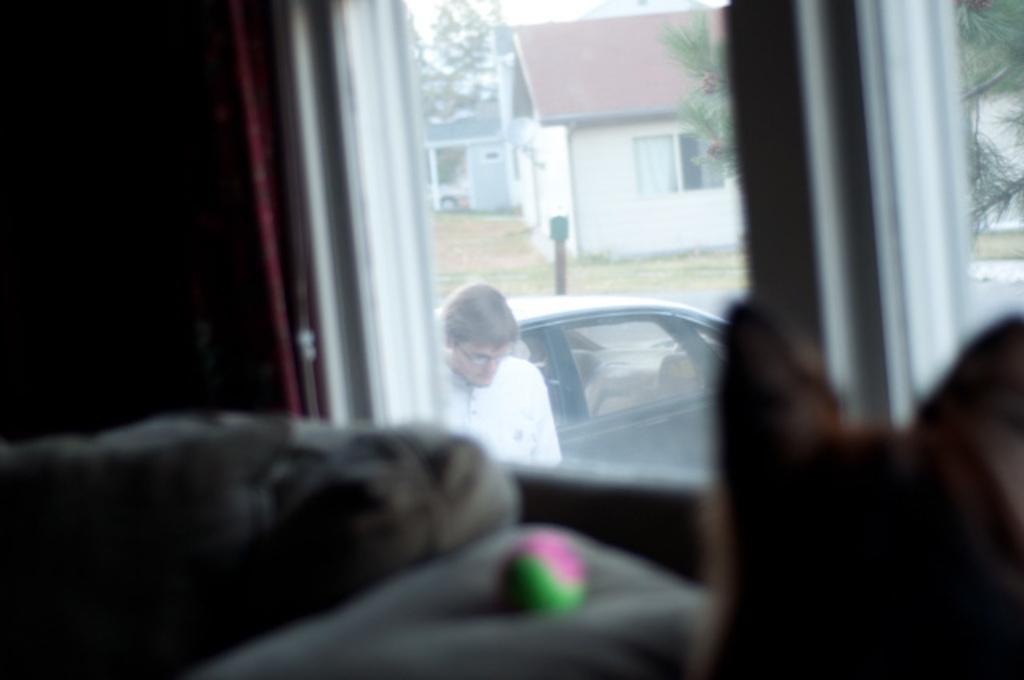Describe this image in one or two sentences. This picture shows a window from the glass of it, We see few houses and we see trees and a car and he wore spectacles on his face and we see a dog and a ball and we see a curtain. 